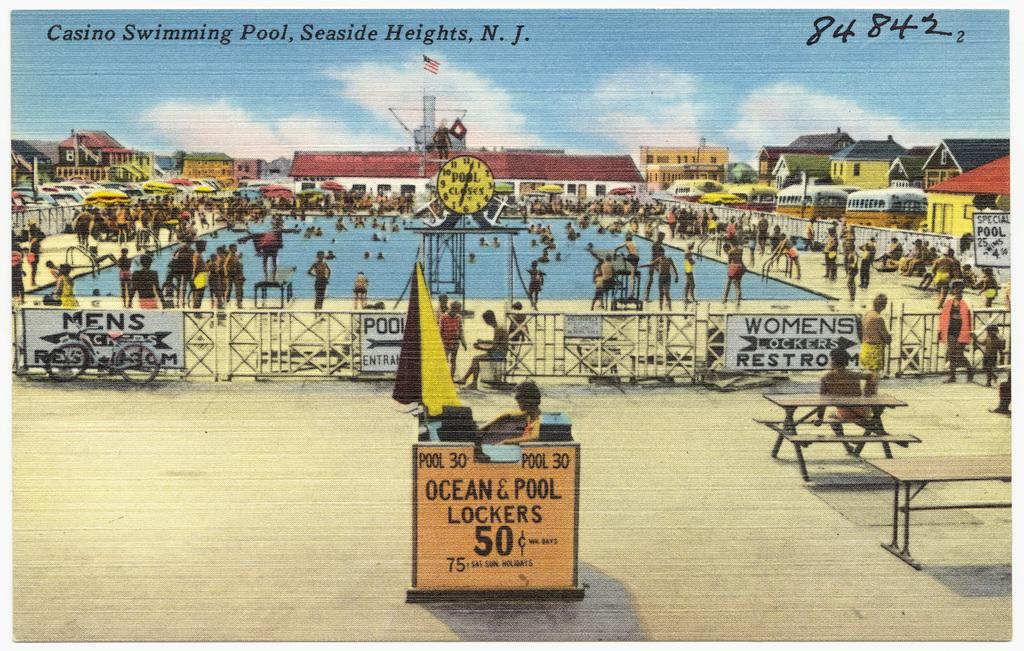<image>
Provide a brief description of the given image. A post card from Casino Swimming Pool, Seaside Heights. 